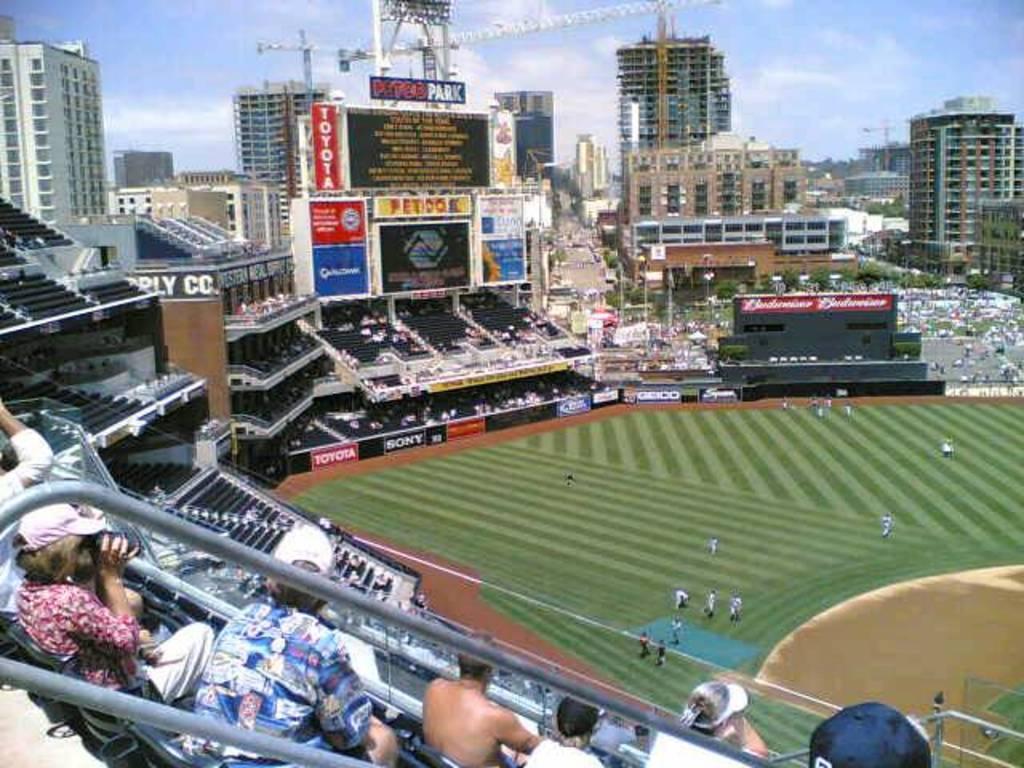Describe this image in one or two sentences. In this picture I can observe playground in the middle of the picture. I can observe stadium in this picture. In the background there are buildings and some clouds in the sky. 